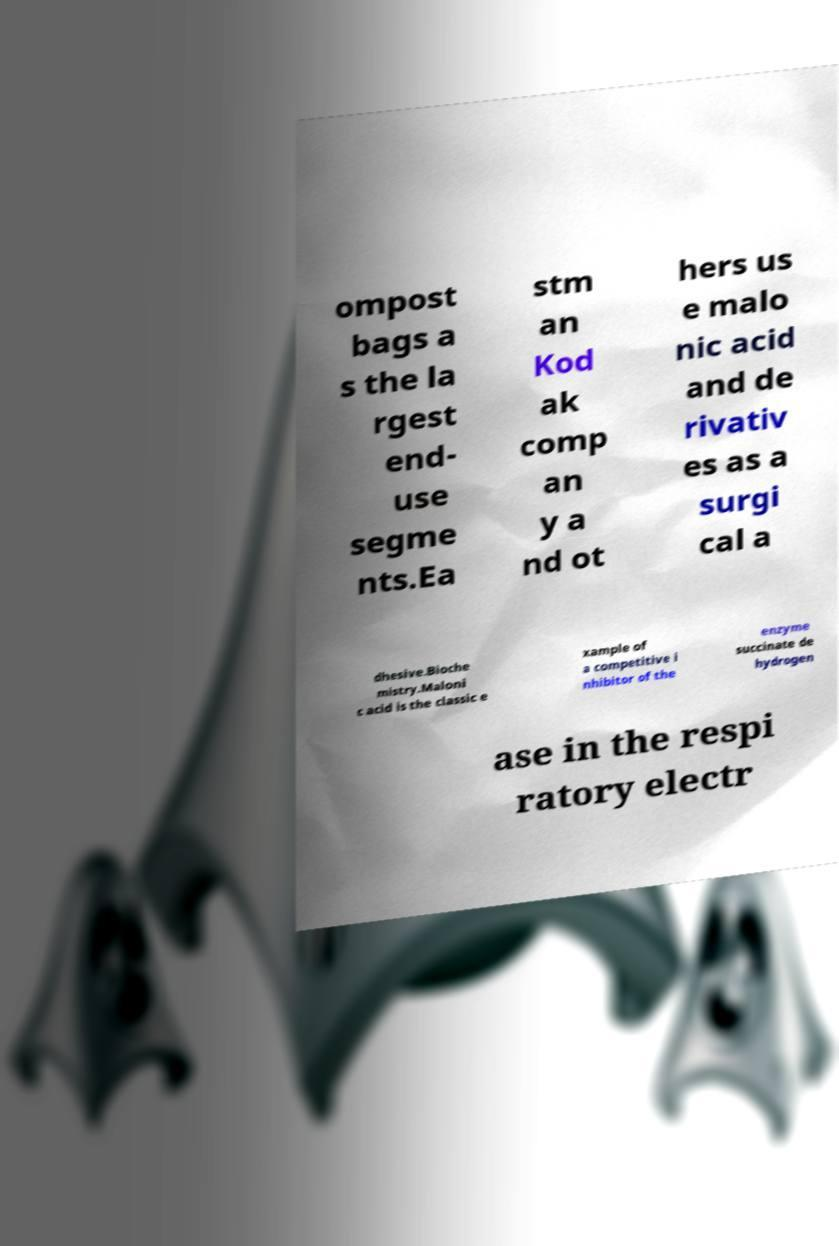Can you read and provide the text displayed in the image?This photo seems to have some interesting text. Can you extract and type it out for me? ompost bags a s the la rgest end- use segme nts.Ea stm an Kod ak comp an y a nd ot hers us e malo nic acid and de rivativ es as a surgi cal a dhesive.Bioche mistry.Maloni c acid is the classic e xample of a competitive i nhibitor of the enzyme succinate de hydrogen ase in the respi ratory electr 